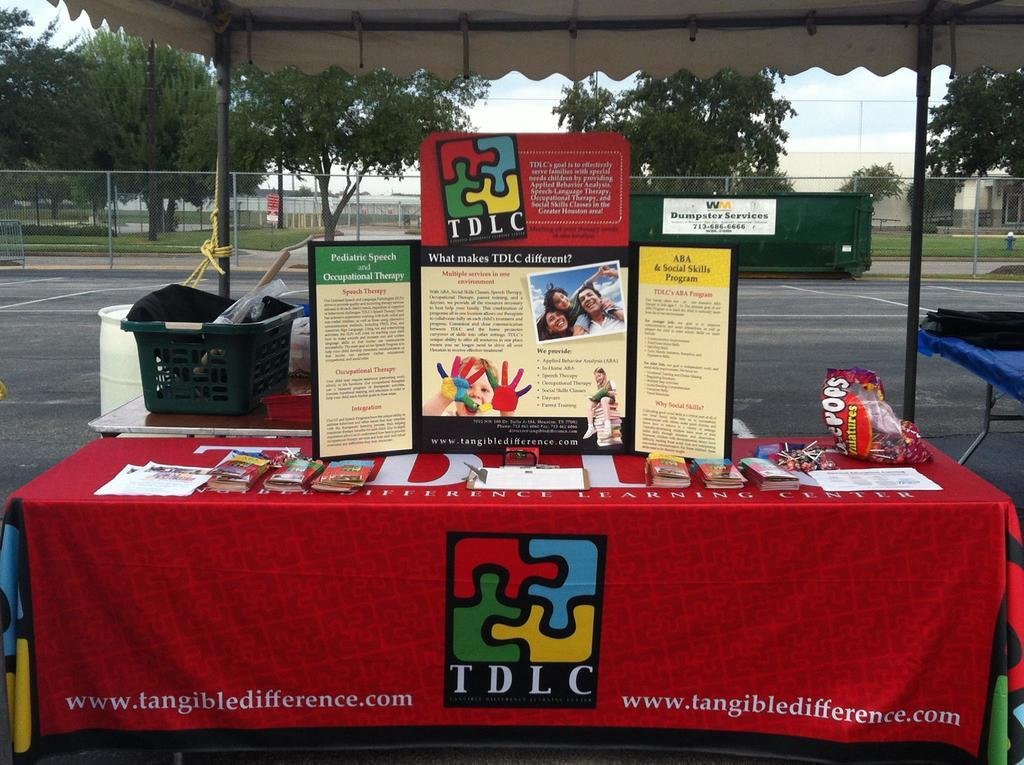<image>
Give a short and clear explanation of the subsequent image. A display table with TDLC written on the front of a red table cloth. 